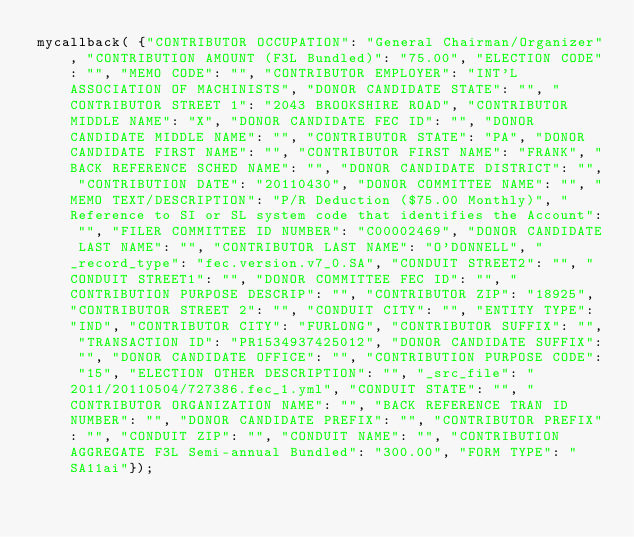Convert code to text. <code><loc_0><loc_0><loc_500><loc_500><_JavaScript_>mycallback( {"CONTRIBUTOR OCCUPATION": "General Chairman/Organizer", "CONTRIBUTION AMOUNT (F3L Bundled)": "75.00", "ELECTION CODE": "", "MEMO CODE": "", "CONTRIBUTOR EMPLOYER": "INT'L ASSOCIATION OF MACHINISTS", "DONOR CANDIDATE STATE": "", "CONTRIBUTOR STREET 1": "2043 BROOKSHIRE ROAD", "CONTRIBUTOR MIDDLE NAME": "X", "DONOR CANDIDATE FEC ID": "", "DONOR CANDIDATE MIDDLE NAME": "", "CONTRIBUTOR STATE": "PA", "DONOR CANDIDATE FIRST NAME": "", "CONTRIBUTOR FIRST NAME": "FRANK", "BACK REFERENCE SCHED NAME": "", "DONOR CANDIDATE DISTRICT": "", "CONTRIBUTION DATE": "20110430", "DONOR COMMITTEE NAME": "", "MEMO TEXT/DESCRIPTION": "P/R Deduction ($75.00 Monthly)", "Reference to SI or SL system code that identifies the Account": "", "FILER COMMITTEE ID NUMBER": "C00002469", "DONOR CANDIDATE LAST NAME": "", "CONTRIBUTOR LAST NAME": "O'DONNELL", "_record_type": "fec.version.v7_0.SA", "CONDUIT STREET2": "", "CONDUIT STREET1": "", "DONOR COMMITTEE FEC ID": "", "CONTRIBUTION PURPOSE DESCRIP": "", "CONTRIBUTOR ZIP": "18925", "CONTRIBUTOR STREET 2": "", "CONDUIT CITY": "", "ENTITY TYPE": "IND", "CONTRIBUTOR CITY": "FURLONG", "CONTRIBUTOR SUFFIX": "", "TRANSACTION ID": "PR1534937425012", "DONOR CANDIDATE SUFFIX": "", "DONOR CANDIDATE OFFICE": "", "CONTRIBUTION PURPOSE CODE": "15", "ELECTION OTHER DESCRIPTION": "", "_src_file": "2011/20110504/727386.fec_1.yml", "CONDUIT STATE": "", "CONTRIBUTOR ORGANIZATION NAME": "", "BACK REFERENCE TRAN ID NUMBER": "", "DONOR CANDIDATE PREFIX": "", "CONTRIBUTOR PREFIX": "", "CONDUIT ZIP": "", "CONDUIT NAME": "", "CONTRIBUTION AGGREGATE F3L Semi-annual Bundled": "300.00", "FORM TYPE": "SA11ai"});
</code> 